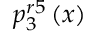Convert formula to latex. <formula><loc_0><loc_0><loc_500><loc_500>p _ { 3 } ^ { r 5 } \left ( x \right )</formula> 